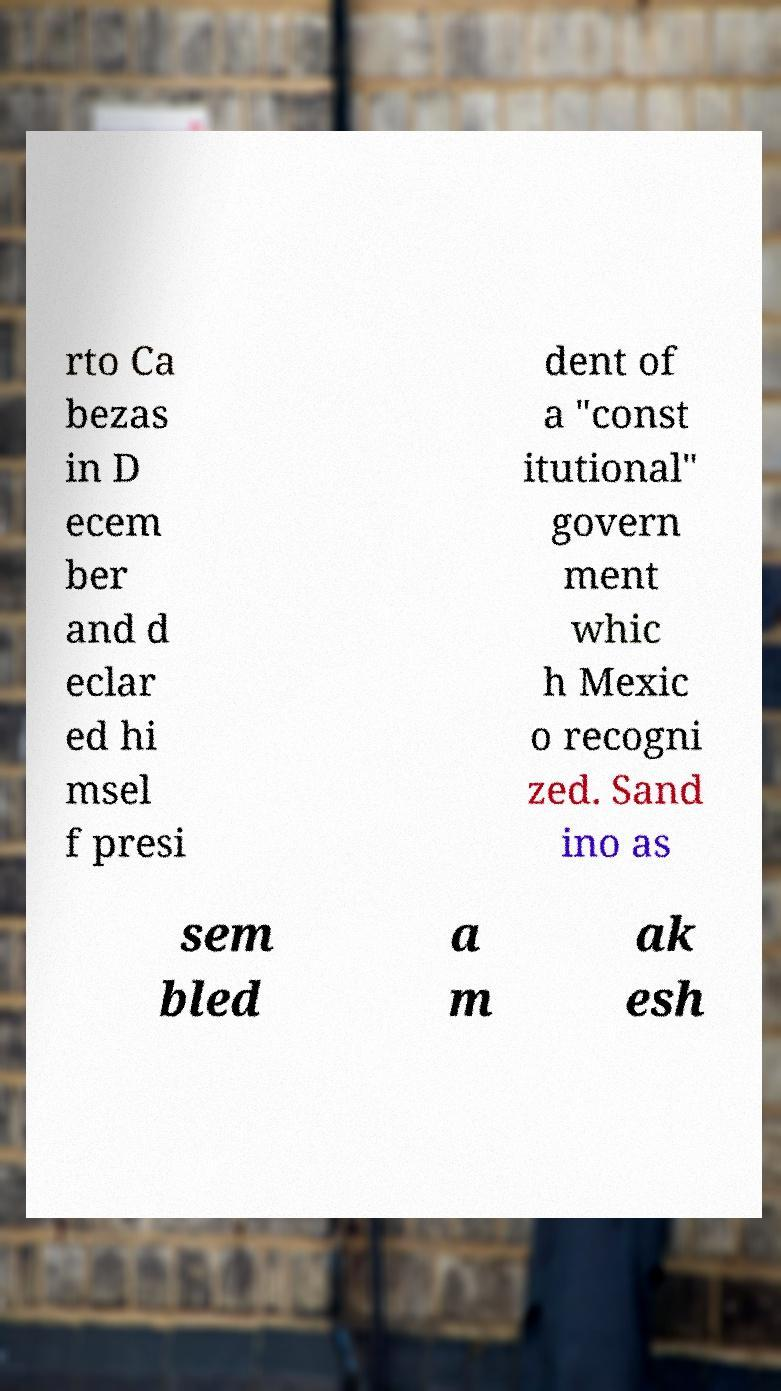I need the written content from this picture converted into text. Can you do that? rto Ca bezas in D ecem ber and d eclar ed hi msel f presi dent of a "const itutional" govern ment whic h Mexic o recogni zed. Sand ino as sem bled a m ak esh 